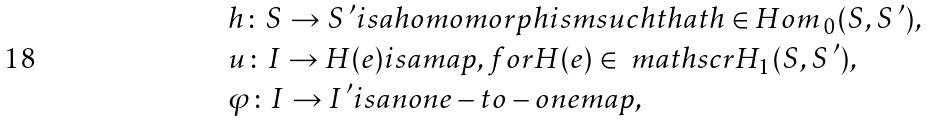<formula> <loc_0><loc_0><loc_500><loc_500>& h \colon S \rightarrow S ^ { \, \prime } i s a h o m o m o r p h i s m s u c h t h a t h \in H o m \, _ { 0 } ( S , S ^ { \, \prime } ) , \\ & u \colon I \rightarrow H ( e ) i s a m a p , f o r H ( e ) \in \ m a t h s c r { H } _ { 1 } ( S , S ^ { \, \prime } ) , \\ & \varphi \colon I \rightarrow I ^ { \, \prime } i s a n o n e - t o - o n e m a p ,</formula> 